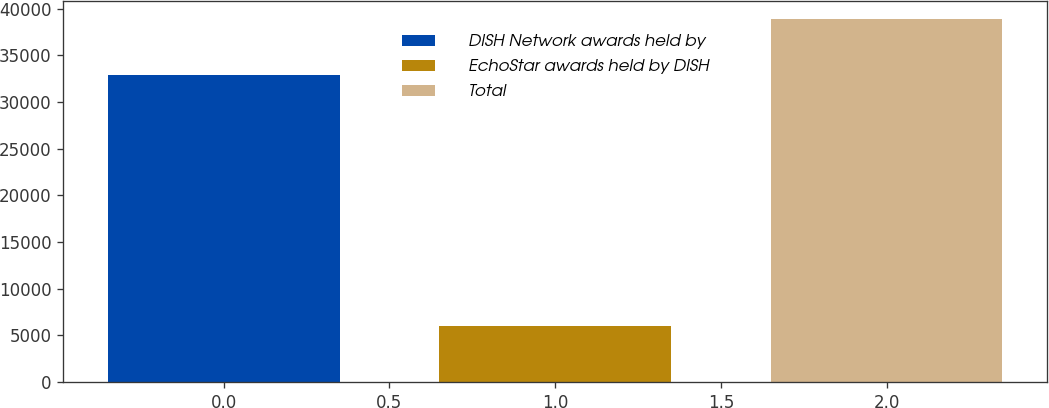<chart> <loc_0><loc_0><loc_500><loc_500><bar_chart><fcel>DISH Network awards held by<fcel>EchoStar awards held by DISH<fcel>Total<nl><fcel>32863<fcel>6032<fcel>38895<nl></chart> 